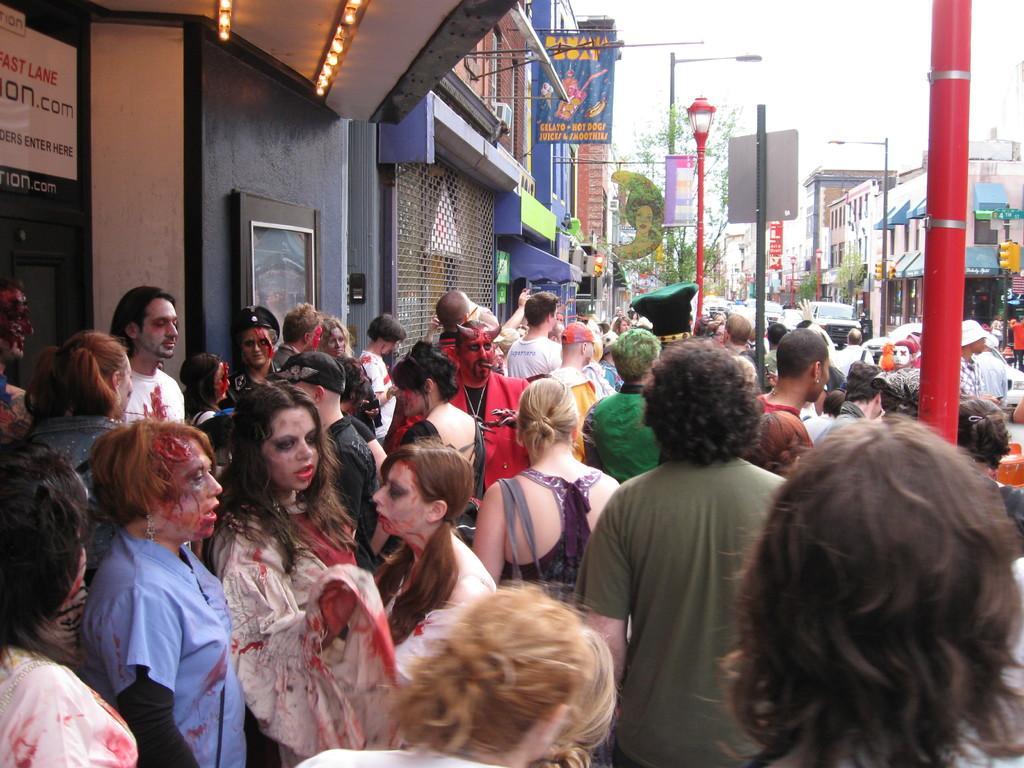Could you give a brief overview of what you see in this image? It is a Halloween party,there is a huge crown standing in front of the building beside the footpath, in the background there are plenty of stores and some trees and sky. 